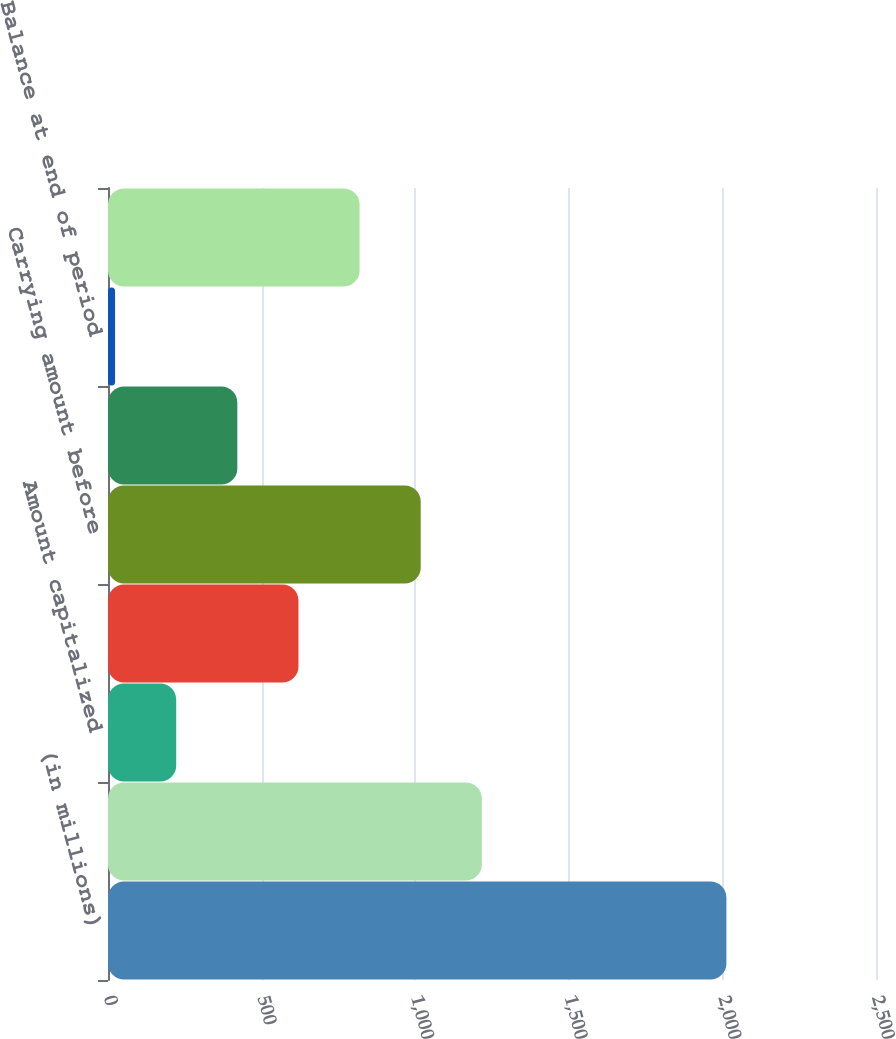Convert chart to OTSL. <chart><loc_0><loc_0><loc_500><loc_500><bar_chart><fcel>(in millions)<fcel>Balance as of January 1<fcel>Amount capitalized<fcel>Amortization<fcel>Carrying amount before<fcel>Valuation (recovery)<fcel>Balance at end of period<fcel>Net carrying value of MSRs<nl><fcel>2013<fcel>1217<fcel>222<fcel>620<fcel>1018<fcel>421<fcel>23<fcel>819<nl></chart> 